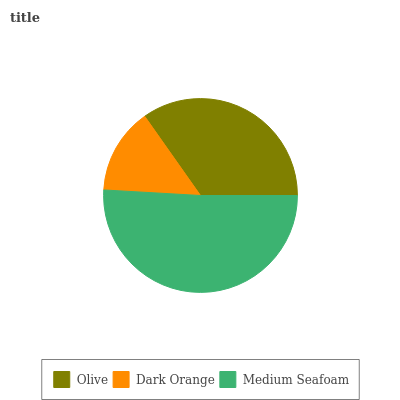Is Dark Orange the minimum?
Answer yes or no. Yes. Is Medium Seafoam the maximum?
Answer yes or no. Yes. Is Medium Seafoam the minimum?
Answer yes or no. No. Is Dark Orange the maximum?
Answer yes or no. No. Is Medium Seafoam greater than Dark Orange?
Answer yes or no. Yes. Is Dark Orange less than Medium Seafoam?
Answer yes or no. Yes. Is Dark Orange greater than Medium Seafoam?
Answer yes or no. No. Is Medium Seafoam less than Dark Orange?
Answer yes or no. No. Is Olive the high median?
Answer yes or no. Yes. Is Olive the low median?
Answer yes or no. Yes. Is Dark Orange the high median?
Answer yes or no. No. Is Medium Seafoam the low median?
Answer yes or no. No. 